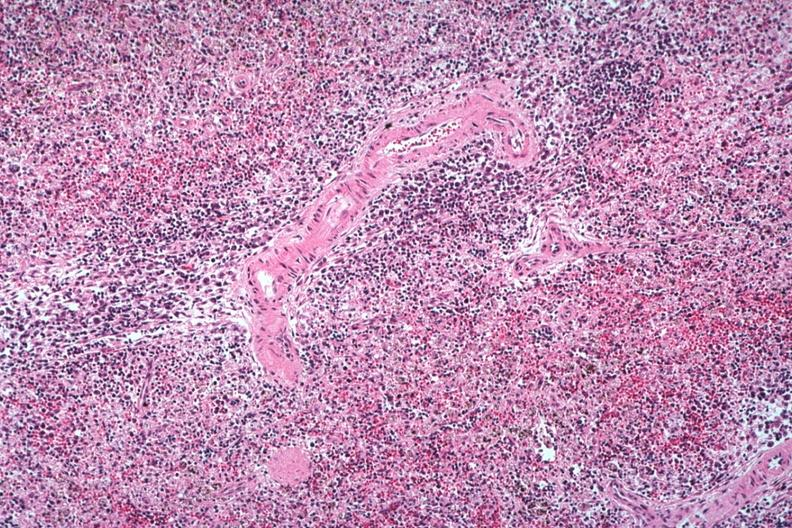what is present?
Answer the question using a single word or phrase. Hematologic 